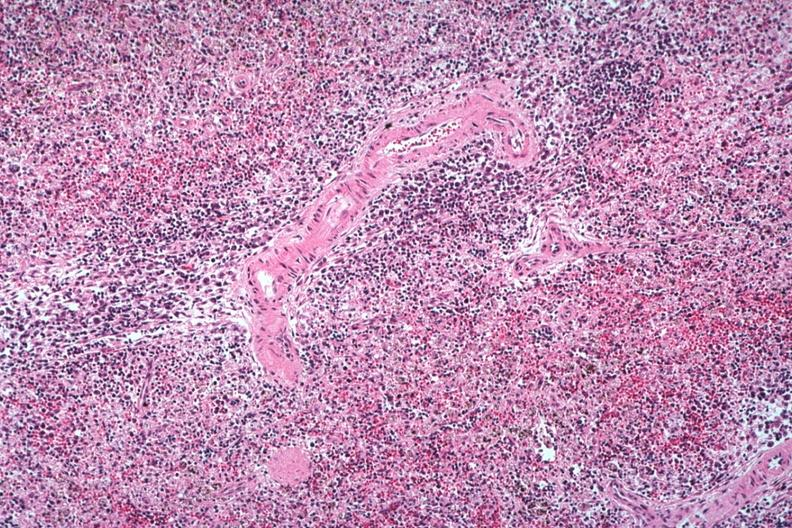what is present?
Answer the question using a single word or phrase. Hematologic 